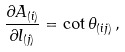Convert formula to latex. <formula><loc_0><loc_0><loc_500><loc_500>\frac { \partial A _ { ( i ) } } { \partial l _ { ( j ) } } = \cot \theta _ { ( i j ) } \, ,</formula> 